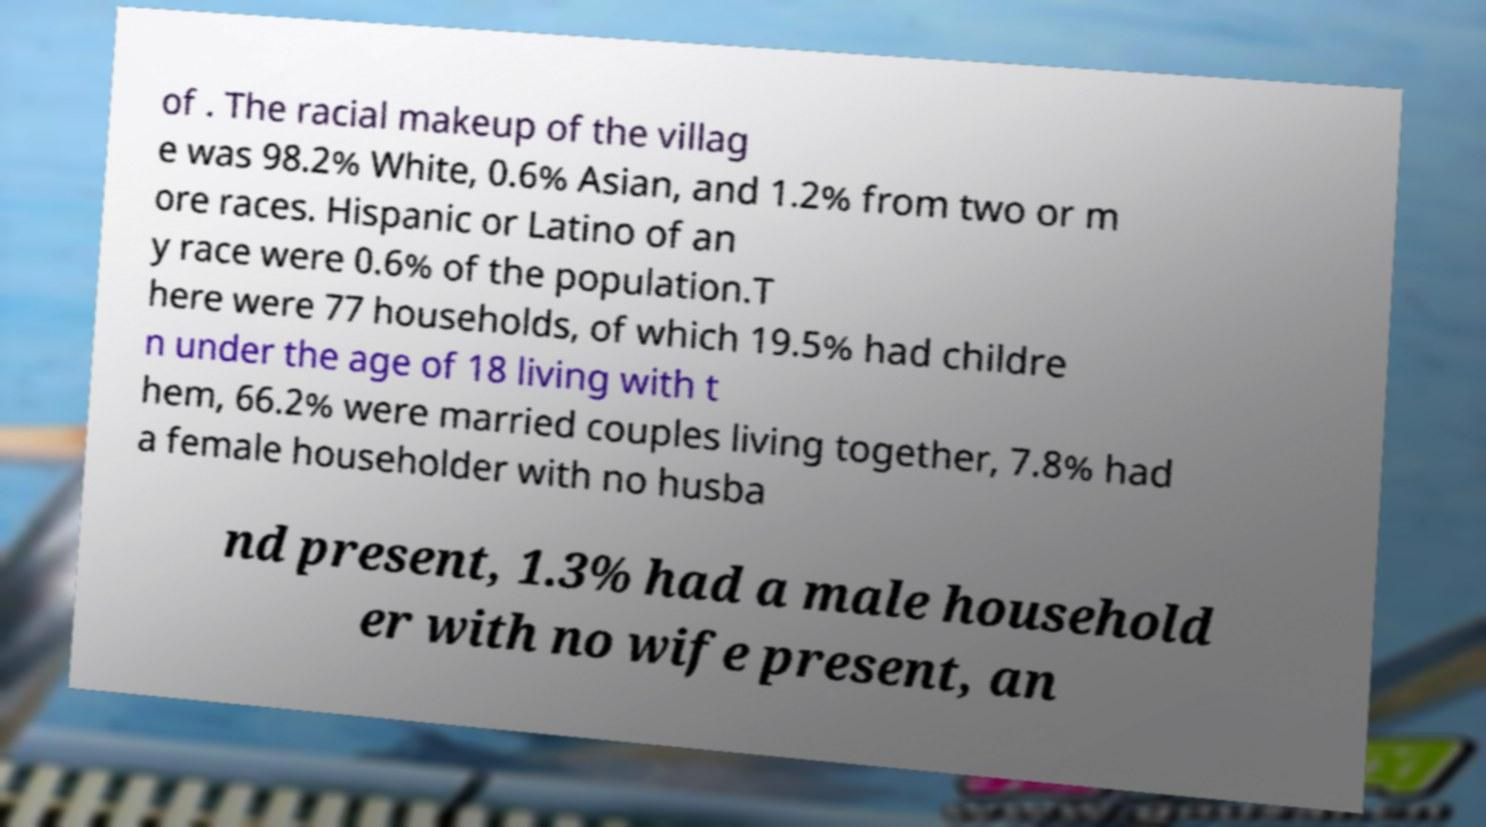Can you accurately transcribe the text from the provided image for me? of . The racial makeup of the villag e was 98.2% White, 0.6% Asian, and 1.2% from two or m ore races. Hispanic or Latino of an y race were 0.6% of the population.T here were 77 households, of which 19.5% had childre n under the age of 18 living with t hem, 66.2% were married couples living together, 7.8% had a female householder with no husba nd present, 1.3% had a male household er with no wife present, an 